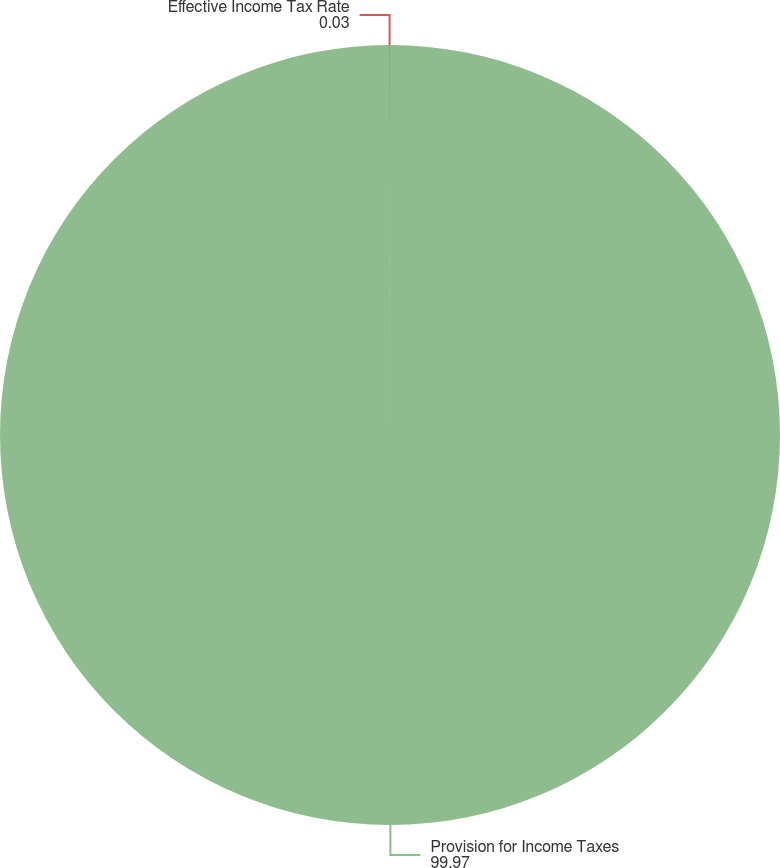<chart> <loc_0><loc_0><loc_500><loc_500><pie_chart><fcel>Provision for Income Taxes<fcel>Effective Income Tax Rate<nl><fcel>99.97%<fcel>0.03%<nl></chart> 